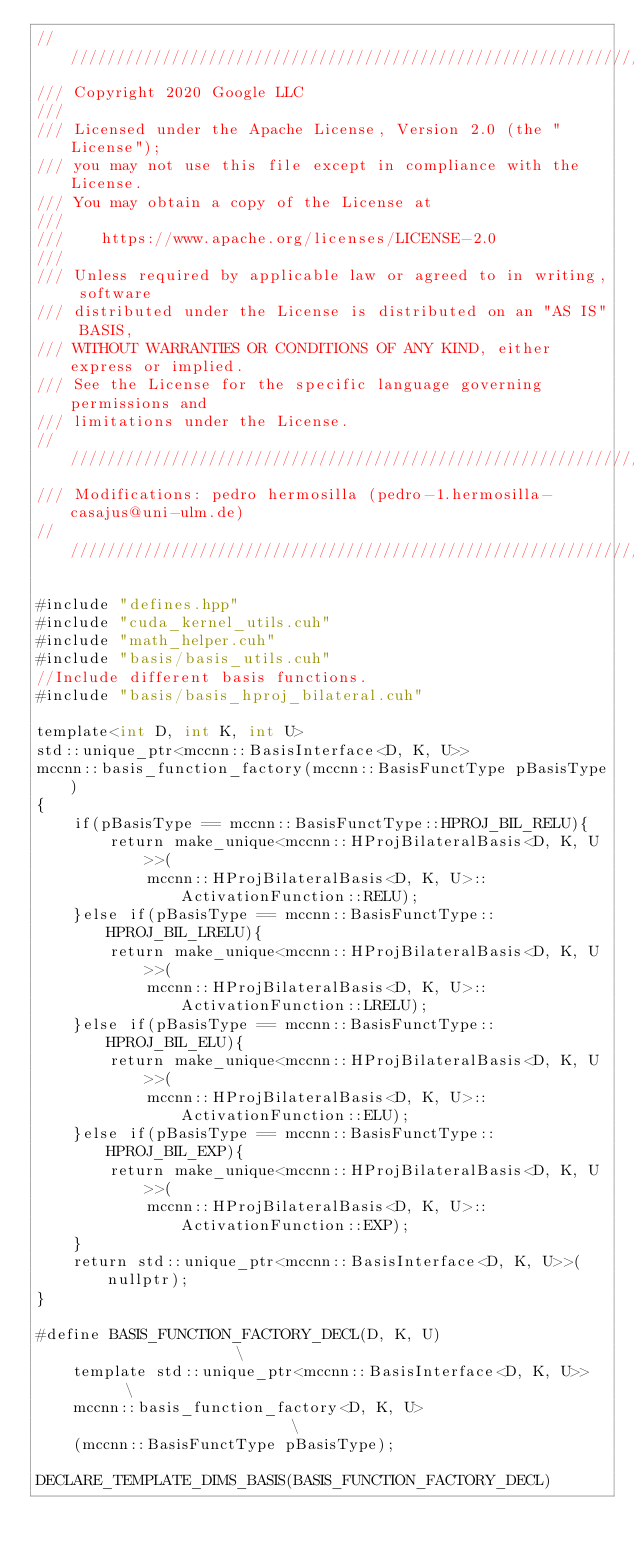Convert code to text. <code><loc_0><loc_0><loc_500><loc_500><_Cuda_>/////////////////////////////////////////////////////////////////////////////
/// Copyright 2020 Google LLC
///
/// Licensed under the Apache License, Version 2.0 (the "License");
/// you may not use this file except in compliance with the License.
/// You may obtain a copy of the License at
///
///    https://www.apache.org/licenses/LICENSE-2.0
///
/// Unless required by applicable law or agreed to in writing, software
/// distributed under the License is distributed on an "AS IS" BASIS,
/// WITHOUT WARRANTIES OR CONDITIONS OF ANY KIND, either express or implied.
/// See the License for the specific language governing permissions and
/// limitations under the License.
/////////////////////////////////////////////////////////////////////////////
/// Modifications: pedro hermosilla (pedro-1.hermosilla-casajus@uni-ulm.de)
/////////////////////////////////////////////////////////////////////////////

#include "defines.hpp"
#include "cuda_kernel_utils.cuh"
#include "math_helper.cuh"
#include "basis/basis_utils.cuh"
//Include different basis functions.
#include "basis/basis_hproj_bilateral.cuh"

template<int D, int K, int U>
std::unique_ptr<mccnn::BasisInterface<D, K, U>> 
mccnn::basis_function_factory(mccnn::BasisFunctType pBasisType)
{
    if(pBasisType == mccnn::BasisFunctType::HPROJ_BIL_RELU){
        return make_unique<mccnn::HProjBilateralBasis<D, K, U>>(
            mccnn::HProjBilateralBasis<D, K, U>::ActivationFunction::RELU);
    }else if(pBasisType == mccnn::BasisFunctType::HPROJ_BIL_LRELU){
        return make_unique<mccnn::HProjBilateralBasis<D, K, U>>(
            mccnn::HProjBilateralBasis<D, K, U>::ActivationFunction::LRELU);
    }else if(pBasisType == mccnn::BasisFunctType::HPROJ_BIL_ELU){
        return make_unique<mccnn::HProjBilateralBasis<D, K, U>>(
            mccnn::HProjBilateralBasis<D, K, U>::ActivationFunction::ELU);
    }else if(pBasisType == mccnn::BasisFunctType::HPROJ_BIL_EXP){
        return make_unique<mccnn::HProjBilateralBasis<D, K, U>>(
            mccnn::HProjBilateralBasis<D, K, U>::ActivationFunction::EXP);
    }
    return std::unique_ptr<mccnn::BasisInterface<D, K, U>>(nullptr);
}

#define BASIS_FUNCTION_FACTORY_DECL(D, K, U)                   \
    template std::unique_ptr<mccnn::BasisInterface<D, K, U>>   \
    mccnn::basis_function_factory<D, K, U>                     \
    (mccnn::BasisFunctType pBasisType);

DECLARE_TEMPLATE_DIMS_BASIS(BASIS_FUNCTION_FACTORY_DECL)</code> 